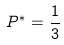Convert formula to latex. <formula><loc_0><loc_0><loc_500><loc_500>P ^ { * } = \frac { 1 } { 3 }</formula> 